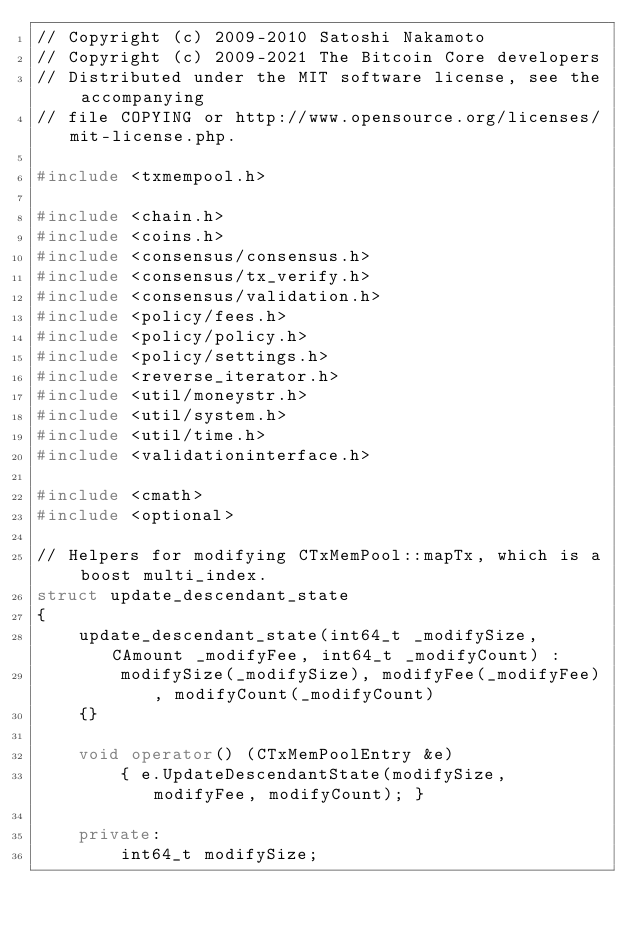Convert code to text. <code><loc_0><loc_0><loc_500><loc_500><_C++_>// Copyright (c) 2009-2010 Satoshi Nakamoto
// Copyright (c) 2009-2021 The Bitcoin Core developers
// Distributed under the MIT software license, see the accompanying
// file COPYING or http://www.opensource.org/licenses/mit-license.php.

#include <txmempool.h>

#include <chain.h>
#include <coins.h>
#include <consensus/consensus.h>
#include <consensus/tx_verify.h>
#include <consensus/validation.h>
#include <policy/fees.h>
#include <policy/policy.h>
#include <policy/settings.h>
#include <reverse_iterator.h>
#include <util/moneystr.h>
#include <util/system.h>
#include <util/time.h>
#include <validationinterface.h>

#include <cmath>
#include <optional>

// Helpers for modifying CTxMemPool::mapTx, which is a boost multi_index.
struct update_descendant_state
{
    update_descendant_state(int64_t _modifySize, CAmount _modifyFee, int64_t _modifyCount) :
        modifySize(_modifySize), modifyFee(_modifyFee), modifyCount(_modifyCount)
    {}

    void operator() (CTxMemPoolEntry &e)
        { e.UpdateDescendantState(modifySize, modifyFee, modifyCount); }

    private:
        int64_t modifySize;</code> 